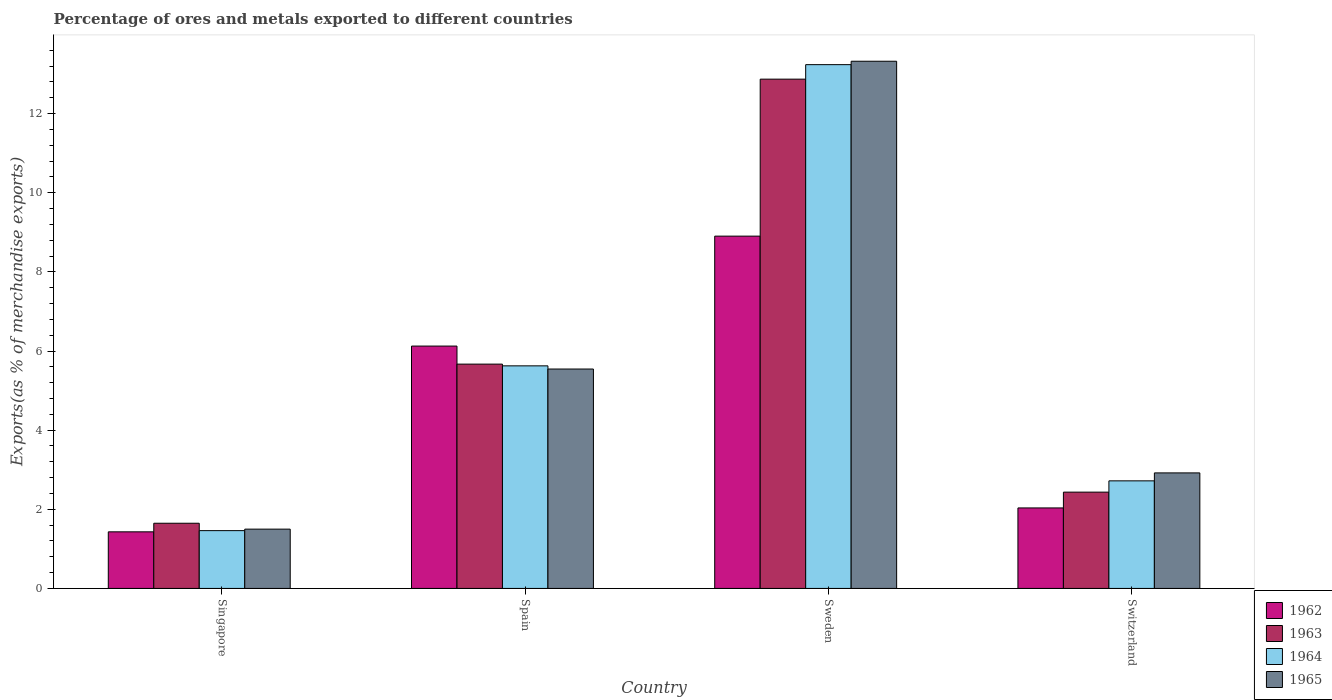How many different coloured bars are there?
Offer a very short reply. 4. Are the number of bars per tick equal to the number of legend labels?
Your answer should be very brief. Yes. How many bars are there on the 2nd tick from the left?
Offer a very short reply. 4. What is the label of the 3rd group of bars from the left?
Offer a very short reply. Sweden. What is the percentage of exports to different countries in 1965 in Switzerland?
Make the answer very short. 2.92. Across all countries, what is the maximum percentage of exports to different countries in 1962?
Offer a terse response. 8.9. Across all countries, what is the minimum percentage of exports to different countries in 1962?
Give a very brief answer. 1.43. In which country was the percentage of exports to different countries in 1963 minimum?
Your answer should be very brief. Singapore. What is the total percentage of exports to different countries in 1962 in the graph?
Your response must be concise. 18.49. What is the difference between the percentage of exports to different countries in 1962 in Spain and that in Switzerland?
Your answer should be compact. 4.09. What is the difference between the percentage of exports to different countries in 1964 in Singapore and the percentage of exports to different countries in 1965 in Spain?
Ensure brevity in your answer.  -4.08. What is the average percentage of exports to different countries in 1964 per country?
Make the answer very short. 5.76. What is the difference between the percentage of exports to different countries of/in 1963 and percentage of exports to different countries of/in 1964 in Switzerland?
Your answer should be very brief. -0.29. What is the ratio of the percentage of exports to different countries in 1965 in Spain to that in Switzerland?
Offer a very short reply. 1.9. What is the difference between the highest and the second highest percentage of exports to different countries in 1962?
Ensure brevity in your answer.  6.87. What is the difference between the highest and the lowest percentage of exports to different countries in 1963?
Your answer should be compact. 11.22. In how many countries, is the percentage of exports to different countries in 1965 greater than the average percentage of exports to different countries in 1965 taken over all countries?
Ensure brevity in your answer.  1. Is the sum of the percentage of exports to different countries in 1965 in Spain and Sweden greater than the maximum percentage of exports to different countries in 1962 across all countries?
Ensure brevity in your answer.  Yes. What does the 2nd bar from the right in Switzerland represents?
Keep it short and to the point. 1964. How many countries are there in the graph?
Ensure brevity in your answer.  4. What is the difference between two consecutive major ticks on the Y-axis?
Provide a succinct answer. 2. Are the values on the major ticks of Y-axis written in scientific E-notation?
Give a very brief answer. No. Does the graph contain grids?
Your response must be concise. No. Where does the legend appear in the graph?
Provide a succinct answer. Bottom right. What is the title of the graph?
Make the answer very short. Percentage of ores and metals exported to different countries. Does "1994" appear as one of the legend labels in the graph?
Provide a succinct answer. No. What is the label or title of the X-axis?
Offer a terse response. Country. What is the label or title of the Y-axis?
Your answer should be very brief. Exports(as % of merchandise exports). What is the Exports(as % of merchandise exports) of 1962 in Singapore?
Provide a succinct answer. 1.43. What is the Exports(as % of merchandise exports) of 1963 in Singapore?
Offer a terse response. 1.65. What is the Exports(as % of merchandise exports) in 1964 in Singapore?
Make the answer very short. 1.46. What is the Exports(as % of merchandise exports) of 1965 in Singapore?
Keep it short and to the point. 1.5. What is the Exports(as % of merchandise exports) in 1962 in Spain?
Make the answer very short. 6.13. What is the Exports(as % of merchandise exports) in 1963 in Spain?
Keep it short and to the point. 5.67. What is the Exports(as % of merchandise exports) in 1964 in Spain?
Provide a succinct answer. 5.63. What is the Exports(as % of merchandise exports) of 1965 in Spain?
Offer a terse response. 5.55. What is the Exports(as % of merchandise exports) in 1962 in Sweden?
Make the answer very short. 8.9. What is the Exports(as % of merchandise exports) of 1963 in Sweden?
Give a very brief answer. 12.87. What is the Exports(as % of merchandise exports) of 1964 in Sweden?
Provide a succinct answer. 13.24. What is the Exports(as % of merchandise exports) in 1965 in Sweden?
Your answer should be very brief. 13.32. What is the Exports(as % of merchandise exports) of 1962 in Switzerland?
Give a very brief answer. 2.03. What is the Exports(as % of merchandise exports) of 1963 in Switzerland?
Provide a short and direct response. 2.43. What is the Exports(as % of merchandise exports) in 1964 in Switzerland?
Keep it short and to the point. 2.72. What is the Exports(as % of merchandise exports) of 1965 in Switzerland?
Ensure brevity in your answer.  2.92. Across all countries, what is the maximum Exports(as % of merchandise exports) of 1962?
Ensure brevity in your answer.  8.9. Across all countries, what is the maximum Exports(as % of merchandise exports) in 1963?
Provide a succinct answer. 12.87. Across all countries, what is the maximum Exports(as % of merchandise exports) in 1964?
Your answer should be very brief. 13.24. Across all countries, what is the maximum Exports(as % of merchandise exports) of 1965?
Offer a very short reply. 13.32. Across all countries, what is the minimum Exports(as % of merchandise exports) in 1962?
Offer a terse response. 1.43. Across all countries, what is the minimum Exports(as % of merchandise exports) of 1963?
Give a very brief answer. 1.65. Across all countries, what is the minimum Exports(as % of merchandise exports) in 1964?
Ensure brevity in your answer.  1.46. Across all countries, what is the minimum Exports(as % of merchandise exports) of 1965?
Provide a short and direct response. 1.5. What is the total Exports(as % of merchandise exports) in 1962 in the graph?
Provide a short and direct response. 18.49. What is the total Exports(as % of merchandise exports) in 1963 in the graph?
Your response must be concise. 22.62. What is the total Exports(as % of merchandise exports) of 1964 in the graph?
Provide a succinct answer. 23.04. What is the total Exports(as % of merchandise exports) in 1965 in the graph?
Make the answer very short. 23.29. What is the difference between the Exports(as % of merchandise exports) in 1962 in Singapore and that in Spain?
Ensure brevity in your answer.  -4.69. What is the difference between the Exports(as % of merchandise exports) in 1963 in Singapore and that in Spain?
Make the answer very short. -4.02. What is the difference between the Exports(as % of merchandise exports) of 1964 in Singapore and that in Spain?
Give a very brief answer. -4.16. What is the difference between the Exports(as % of merchandise exports) of 1965 in Singapore and that in Spain?
Give a very brief answer. -4.05. What is the difference between the Exports(as % of merchandise exports) of 1962 in Singapore and that in Sweden?
Provide a succinct answer. -7.47. What is the difference between the Exports(as % of merchandise exports) in 1963 in Singapore and that in Sweden?
Offer a terse response. -11.22. What is the difference between the Exports(as % of merchandise exports) in 1964 in Singapore and that in Sweden?
Keep it short and to the point. -11.78. What is the difference between the Exports(as % of merchandise exports) of 1965 in Singapore and that in Sweden?
Provide a succinct answer. -11.83. What is the difference between the Exports(as % of merchandise exports) in 1962 in Singapore and that in Switzerland?
Offer a very short reply. -0.6. What is the difference between the Exports(as % of merchandise exports) of 1963 in Singapore and that in Switzerland?
Offer a terse response. -0.79. What is the difference between the Exports(as % of merchandise exports) of 1964 in Singapore and that in Switzerland?
Provide a succinct answer. -1.26. What is the difference between the Exports(as % of merchandise exports) of 1965 in Singapore and that in Switzerland?
Your response must be concise. -1.42. What is the difference between the Exports(as % of merchandise exports) in 1962 in Spain and that in Sweden?
Keep it short and to the point. -2.78. What is the difference between the Exports(as % of merchandise exports) in 1963 in Spain and that in Sweden?
Your response must be concise. -7.2. What is the difference between the Exports(as % of merchandise exports) of 1964 in Spain and that in Sweden?
Ensure brevity in your answer.  -7.61. What is the difference between the Exports(as % of merchandise exports) of 1965 in Spain and that in Sweden?
Offer a terse response. -7.78. What is the difference between the Exports(as % of merchandise exports) of 1962 in Spain and that in Switzerland?
Provide a short and direct response. 4.09. What is the difference between the Exports(as % of merchandise exports) of 1963 in Spain and that in Switzerland?
Keep it short and to the point. 3.24. What is the difference between the Exports(as % of merchandise exports) in 1964 in Spain and that in Switzerland?
Your answer should be compact. 2.91. What is the difference between the Exports(as % of merchandise exports) in 1965 in Spain and that in Switzerland?
Ensure brevity in your answer.  2.63. What is the difference between the Exports(as % of merchandise exports) in 1962 in Sweden and that in Switzerland?
Provide a succinct answer. 6.87. What is the difference between the Exports(as % of merchandise exports) in 1963 in Sweden and that in Switzerland?
Offer a terse response. 10.44. What is the difference between the Exports(as % of merchandise exports) in 1964 in Sweden and that in Switzerland?
Provide a succinct answer. 10.52. What is the difference between the Exports(as % of merchandise exports) of 1965 in Sweden and that in Switzerland?
Offer a terse response. 10.4. What is the difference between the Exports(as % of merchandise exports) in 1962 in Singapore and the Exports(as % of merchandise exports) in 1963 in Spain?
Give a very brief answer. -4.24. What is the difference between the Exports(as % of merchandise exports) in 1962 in Singapore and the Exports(as % of merchandise exports) in 1964 in Spain?
Offer a terse response. -4.2. What is the difference between the Exports(as % of merchandise exports) of 1962 in Singapore and the Exports(as % of merchandise exports) of 1965 in Spain?
Your response must be concise. -4.11. What is the difference between the Exports(as % of merchandise exports) in 1963 in Singapore and the Exports(as % of merchandise exports) in 1964 in Spain?
Make the answer very short. -3.98. What is the difference between the Exports(as % of merchandise exports) of 1963 in Singapore and the Exports(as % of merchandise exports) of 1965 in Spain?
Make the answer very short. -3.9. What is the difference between the Exports(as % of merchandise exports) in 1964 in Singapore and the Exports(as % of merchandise exports) in 1965 in Spain?
Keep it short and to the point. -4.08. What is the difference between the Exports(as % of merchandise exports) in 1962 in Singapore and the Exports(as % of merchandise exports) in 1963 in Sweden?
Ensure brevity in your answer.  -11.44. What is the difference between the Exports(as % of merchandise exports) of 1962 in Singapore and the Exports(as % of merchandise exports) of 1964 in Sweden?
Your answer should be compact. -11.81. What is the difference between the Exports(as % of merchandise exports) of 1962 in Singapore and the Exports(as % of merchandise exports) of 1965 in Sweden?
Offer a very short reply. -11.89. What is the difference between the Exports(as % of merchandise exports) in 1963 in Singapore and the Exports(as % of merchandise exports) in 1964 in Sweden?
Your answer should be very brief. -11.59. What is the difference between the Exports(as % of merchandise exports) in 1963 in Singapore and the Exports(as % of merchandise exports) in 1965 in Sweden?
Give a very brief answer. -11.68. What is the difference between the Exports(as % of merchandise exports) in 1964 in Singapore and the Exports(as % of merchandise exports) in 1965 in Sweden?
Keep it short and to the point. -11.86. What is the difference between the Exports(as % of merchandise exports) in 1962 in Singapore and the Exports(as % of merchandise exports) in 1963 in Switzerland?
Provide a succinct answer. -1. What is the difference between the Exports(as % of merchandise exports) of 1962 in Singapore and the Exports(as % of merchandise exports) of 1964 in Switzerland?
Offer a terse response. -1.29. What is the difference between the Exports(as % of merchandise exports) of 1962 in Singapore and the Exports(as % of merchandise exports) of 1965 in Switzerland?
Keep it short and to the point. -1.49. What is the difference between the Exports(as % of merchandise exports) of 1963 in Singapore and the Exports(as % of merchandise exports) of 1964 in Switzerland?
Offer a terse response. -1.07. What is the difference between the Exports(as % of merchandise exports) in 1963 in Singapore and the Exports(as % of merchandise exports) in 1965 in Switzerland?
Offer a very short reply. -1.27. What is the difference between the Exports(as % of merchandise exports) in 1964 in Singapore and the Exports(as % of merchandise exports) in 1965 in Switzerland?
Offer a very short reply. -1.46. What is the difference between the Exports(as % of merchandise exports) in 1962 in Spain and the Exports(as % of merchandise exports) in 1963 in Sweden?
Your answer should be very brief. -6.75. What is the difference between the Exports(as % of merchandise exports) of 1962 in Spain and the Exports(as % of merchandise exports) of 1964 in Sweden?
Make the answer very short. -7.11. What is the difference between the Exports(as % of merchandise exports) in 1962 in Spain and the Exports(as % of merchandise exports) in 1965 in Sweden?
Provide a succinct answer. -7.2. What is the difference between the Exports(as % of merchandise exports) of 1963 in Spain and the Exports(as % of merchandise exports) of 1964 in Sweden?
Give a very brief answer. -7.57. What is the difference between the Exports(as % of merchandise exports) in 1963 in Spain and the Exports(as % of merchandise exports) in 1965 in Sweden?
Provide a succinct answer. -7.65. What is the difference between the Exports(as % of merchandise exports) in 1964 in Spain and the Exports(as % of merchandise exports) in 1965 in Sweden?
Ensure brevity in your answer.  -7.7. What is the difference between the Exports(as % of merchandise exports) of 1962 in Spain and the Exports(as % of merchandise exports) of 1963 in Switzerland?
Give a very brief answer. 3.69. What is the difference between the Exports(as % of merchandise exports) in 1962 in Spain and the Exports(as % of merchandise exports) in 1964 in Switzerland?
Your response must be concise. 3.41. What is the difference between the Exports(as % of merchandise exports) of 1962 in Spain and the Exports(as % of merchandise exports) of 1965 in Switzerland?
Offer a very short reply. 3.21. What is the difference between the Exports(as % of merchandise exports) of 1963 in Spain and the Exports(as % of merchandise exports) of 1964 in Switzerland?
Your answer should be compact. 2.95. What is the difference between the Exports(as % of merchandise exports) of 1963 in Spain and the Exports(as % of merchandise exports) of 1965 in Switzerland?
Make the answer very short. 2.75. What is the difference between the Exports(as % of merchandise exports) of 1964 in Spain and the Exports(as % of merchandise exports) of 1965 in Switzerland?
Your answer should be very brief. 2.71. What is the difference between the Exports(as % of merchandise exports) of 1962 in Sweden and the Exports(as % of merchandise exports) of 1963 in Switzerland?
Ensure brevity in your answer.  6.47. What is the difference between the Exports(as % of merchandise exports) in 1962 in Sweden and the Exports(as % of merchandise exports) in 1964 in Switzerland?
Provide a succinct answer. 6.18. What is the difference between the Exports(as % of merchandise exports) in 1962 in Sweden and the Exports(as % of merchandise exports) in 1965 in Switzerland?
Your answer should be very brief. 5.98. What is the difference between the Exports(as % of merchandise exports) in 1963 in Sweden and the Exports(as % of merchandise exports) in 1964 in Switzerland?
Give a very brief answer. 10.15. What is the difference between the Exports(as % of merchandise exports) in 1963 in Sweden and the Exports(as % of merchandise exports) in 1965 in Switzerland?
Your answer should be compact. 9.95. What is the difference between the Exports(as % of merchandise exports) in 1964 in Sweden and the Exports(as % of merchandise exports) in 1965 in Switzerland?
Your response must be concise. 10.32. What is the average Exports(as % of merchandise exports) in 1962 per country?
Make the answer very short. 4.62. What is the average Exports(as % of merchandise exports) in 1963 per country?
Provide a succinct answer. 5.66. What is the average Exports(as % of merchandise exports) of 1964 per country?
Ensure brevity in your answer.  5.76. What is the average Exports(as % of merchandise exports) in 1965 per country?
Provide a succinct answer. 5.82. What is the difference between the Exports(as % of merchandise exports) of 1962 and Exports(as % of merchandise exports) of 1963 in Singapore?
Make the answer very short. -0.22. What is the difference between the Exports(as % of merchandise exports) of 1962 and Exports(as % of merchandise exports) of 1964 in Singapore?
Provide a succinct answer. -0.03. What is the difference between the Exports(as % of merchandise exports) of 1962 and Exports(as % of merchandise exports) of 1965 in Singapore?
Make the answer very short. -0.07. What is the difference between the Exports(as % of merchandise exports) of 1963 and Exports(as % of merchandise exports) of 1964 in Singapore?
Your response must be concise. 0.19. What is the difference between the Exports(as % of merchandise exports) of 1963 and Exports(as % of merchandise exports) of 1965 in Singapore?
Provide a succinct answer. 0.15. What is the difference between the Exports(as % of merchandise exports) in 1964 and Exports(as % of merchandise exports) in 1965 in Singapore?
Give a very brief answer. -0.04. What is the difference between the Exports(as % of merchandise exports) of 1962 and Exports(as % of merchandise exports) of 1963 in Spain?
Make the answer very short. 0.46. What is the difference between the Exports(as % of merchandise exports) in 1962 and Exports(as % of merchandise exports) in 1964 in Spain?
Offer a terse response. 0.5. What is the difference between the Exports(as % of merchandise exports) in 1962 and Exports(as % of merchandise exports) in 1965 in Spain?
Ensure brevity in your answer.  0.58. What is the difference between the Exports(as % of merchandise exports) of 1963 and Exports(as % of merchandise exports) of 1964 in Spain?
Your response must be concise. 0.04. What is the difference between the Exports(as % of merchandise exports) in 1963 and Exports(as % of merchandise exports) in 1965 in Spain?
Ensure brevity in your answer.  0.12. What is the difference between the Exports(as % of merchandise exports) in 1964 and Exports(as % of merchandise exports) in 1965 in Spain?
Provide a succinct answer. 0.08. What is the difference between the Exports(as % of merchandise exports) of 1962 and Exports(as % of merchandise exports) of 1963 in Sweden?
Your answer should be very brief. -3.97. What is the difference between the Exports(as % of merchandise exports) of 1962 and Exports(as % of merchandise exports) of 1964 in Sweden?
Keep it short and to the point. -4.33. What is the difference between the Exports(as % of merchandise exports) in 1962 and Exports(as % of merchandise exports) in 1965 in Sweden?
Make the answer very short. -4.42. What is the difference between the Exports(as % of merchandise exports) in 1963 and Exports(as % of merchandise exports) in 1964 in Sweden?
Your response must be concise. -0.37. What is the difference between the Exports(as % of merchandise exports) of 1963 and Exports(as % of merchandise exports) of 1965 in Sweden?
Offer a terse response. -0.45. What is the difference between the Exports(as % of merchandise exports) of 1964 and Exports(as % of merchandise exports) of 1965 in Sweden?
Give a very brief answer. -0.09. What is the difference between the Exports(as % of merchandise exports) of 1962 and Exports(as % of merchandise exports) of 1963 in Switzerland?
Keep it short and to the point. -0.4. What is the difference between the Exports(as % of merchandise exports) of 1962 and Exports(as % of merchandise exports) of 1964 in Switzerland?
Offer a terse response. -0.68. What is the difference between the Exports(as % of merchandise exports) of 1962 and Exports(as % of merchandise exports) of 1965 in Switzerland?
Keep it short and to the point. -0.89. What is the difference between the Exports(as % of merchandise exports) of 1963 and Exports(as % of merchandise exports) of 1964 in Switzerland?
Offer a terse response. -0.29. What is the difference between the Exports(as % of merchandise exports) of 1963 and Exports(as % of merchandise exports) of 1965 in Switzerland?
Offer a very short reply. -0.49. What is the difference between the Exports(as % of merchandise exports) in 1964 and Exports(as % of merchandise exports) in 1965 in Switzerland?
Provide a succinct answer. -0.2. What is the ratio of the Exports(as % of merchandise exports) of 1962 in Singapore to that in Spain?
Provide a short and direct response. 0.23. What is the ratio of the Exports(as % of merchandise exports) of 1963 in Singapore to that in Spain?
Your answer should be compact. 0.29. What is the ratio of the Exports(as % of merchandise exports) of 1964 in Singapore to that in Spain?
Give a very brief answer. 0.26. What is the ratio of the Exports(as % of merchandise exports) of 1965 in Singapore to that in Spain?
Ensure brevity in your answer.  0.27. What is the ratio of the Exports(as % of merchandise exports) in 1962 in Singapore to that in Sweden?
Keep it short and to the point. 0.16. What is the ratio of the Exports(as % of merchandise exports) of 1963 in Singapore to that in Sweden?
Provide a short and direct response. 0.13. What is the ratio of the Exports(as % of merchandise exports) in 1964 in Singapore to that in Sweden?
Provide a short and direct response. 0.11. What is the ratio of the Exports(as % of merchandise exports) in 1965 in Singapore to that in Sweden?
Provide a succinct answer. 0.11. What is the ratio of the Exports(as % of merchandise exports) of 1962 in Singapore to that in Switzerland?
Make the answer very short. 0.7. What is the ratio of the Exports(as % of merchandise exports) in 1963 in Singapore to that in Switzerland?
Your answer should be compact. 0.68. What is the ratio of the Exports(as % of merchandise exports) of 1964 in Singapore to that in Switzerland?
Offer a terse response. 0.54. What is the ratio of the Exports(as % of merchandise exports) in 1965 in Singapore to that in Switzerland?
Make the answer very short. 0.51. What is the ratio of the Exports(as % of merchandise exports) of 1962 in Spain to that in Sweden?
Provide a short and direct response. 0.69. What is the ratio of the Exports(as % of merchandise exports) in 1963 in Spain to that in Sweden?
Ensure brevity in your answer.  0.44. What is the ratio of the Exports(as % of merchandise exports) in 1964 in Spain to that in Sweden?
Your answer should be very brief. 0.42. What is the ratio of the Exports(as % of merchandise exports) in 1965 in Spain to that in Sweden?
Offer a terse response. 0.42. What is the ratio of the Exports(as % of merchandise exports) in 1962 in Spain to that in Switzerland?
Your response must be concise. 3.01. What is the ratio of the Exports(as % of merchandise exports) of 1963 in Spain to that in Switzerland?
Your answer should be compact. 2.33. What is the ratio of the Exports(as % of merchandise exports) in 1964 in Spain to that in Switzerland?
Keep it short and to the point. 2.07. What is the ratio of the Exports(as % of merchandise exports) of 1965 in Spain to that in Switzerland?
Ensure brevity in your answer.  1.9. What is the ratio of the Exports(as % of merchandise exports) of 1962 in Sweden to that in Switzerland?
Give a very brief answer. 4.38. What is the ratio of the Exports(as % of merchandise exports) in 1963 in Sweden to that in Switzerland?
Your response must be concise. 5.29. What is the ratio of the Exports(as % of merchandise exports) in 1964 in Sweden to that in Switzerland?
Give a very brief answer. 4.87. What is the ratio of the Exports(as % of merchandise exports) in 1965 in Sweden to that in Switzerland?
Ensure brevity in your answer.  4.56. What is the difference between the highest and the second highest Exports(as % of merchandise exports) in 1962?
Ensure brevity in your answer.  2.78. What is the difference between the highest and the second highest Exports(as % of merchandise exports) of 1963?
Ensure brevity in your answer.  7.2. What is the difference between the highest and the second highest Exports(as % of merchandise exports) in 1964?
Keep it short and to the point. 7.61. What is the difference between the highest and the second highest Exports(as % of merchandise exports) of 1965?
Ensure brevity in your answer.  7.78. What is the difference between the highest and the lowest Exports(as % of merchandise exports) of 1962?
Your answer should be compact. 7.47. What is the difference between the highest and the lowest Exports(as % of merchandise exports) in 1963?
Your response must be concise. 11.22. What is the difference between the highest and the lowest Exports(as % of merchandise exports) in 1964?
Offer a terse response. 11.78. What is the difference between the highest and the lowest Exports(as % of merchandise exports) of 1965?
Provide a succinct answer. 11.83. 